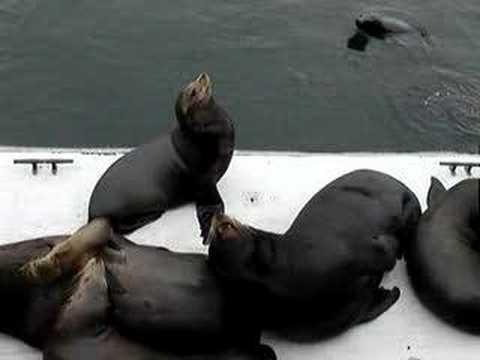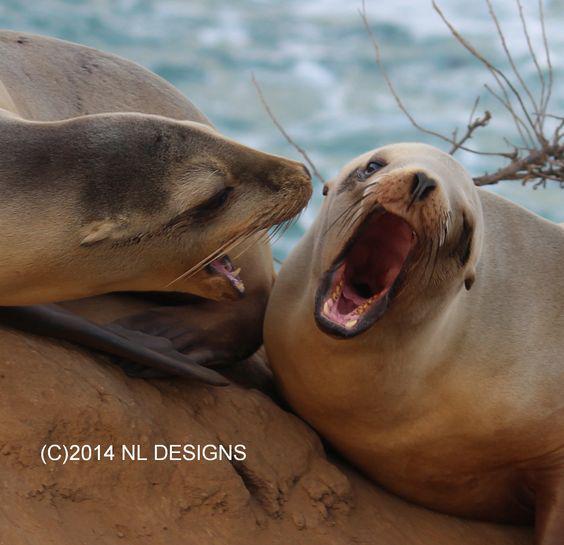The first image is the image on the left, the second image is the image on the right. Considering the images on both sides, is "Right image shows multiple seals on a rock, and no seals have opened mouths." valid? Answer yes or no. No. The first image is the image on the left, the second image is the image on the right. For the images displayed, is the sentence "Two seals are sitting on a rock in the image on the left." factually correct? Answer yes or no. No. 